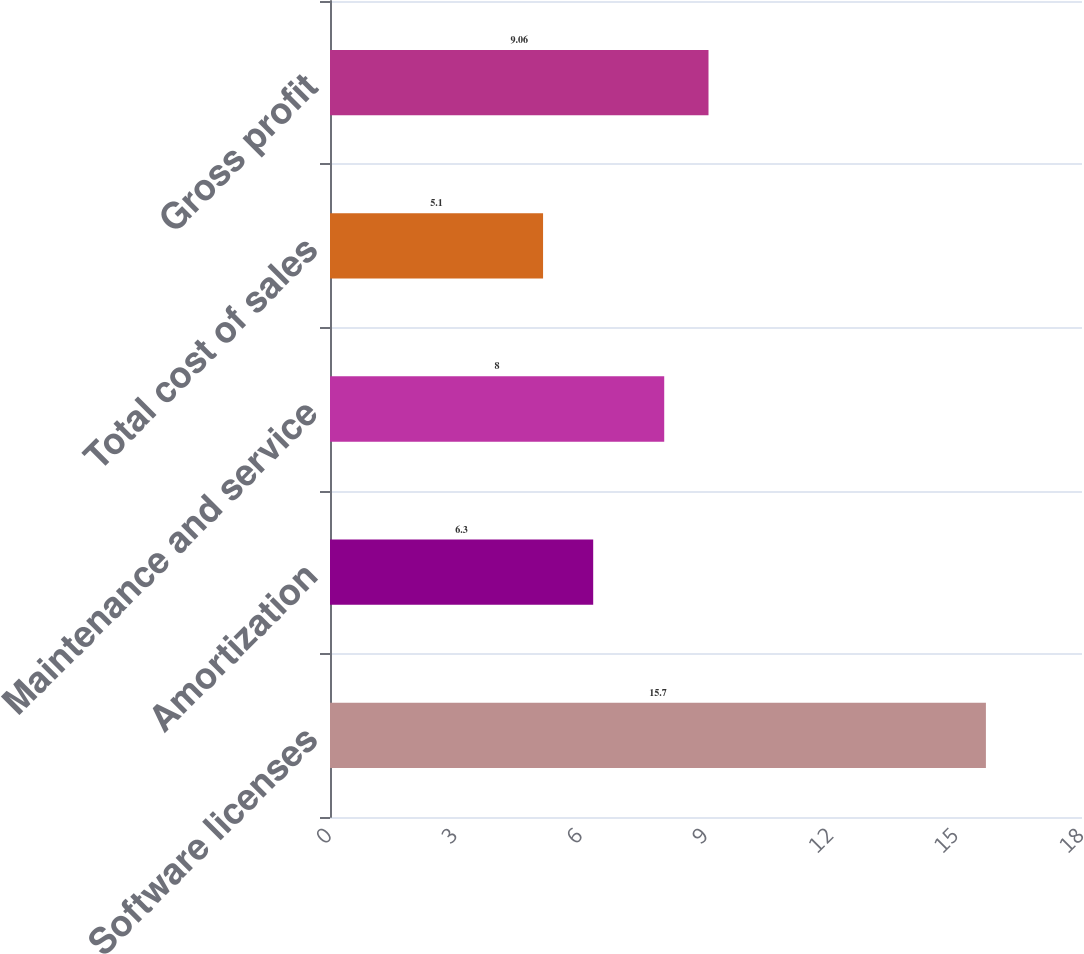<chart> <loc_0><loc_0><loc_500><loc_500><bar_chart><fcel>Software licenses<fcel>Amortization<fcel>Maintenance and service<fcel>Total cost of sales<fcel>Gross profit<nl><fcel>15.7<fcel>6.3<fcel>8<fcel>5.1<fcel>9.06<nl></chart> 